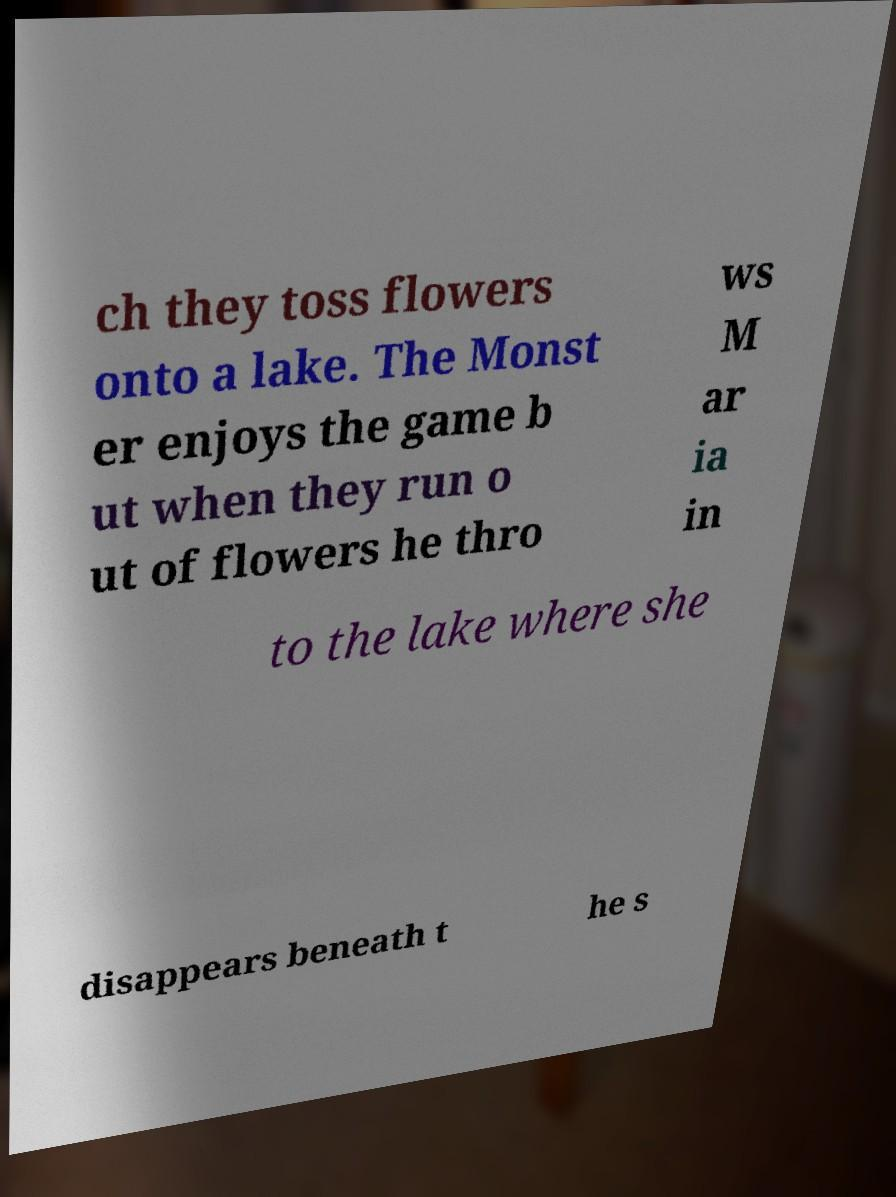What messages or text are displayed in this image? I need them in a readable, typed format. ch they toss flowers onto a lake. The Monst er enjoys the game b ut when they run o ut of flowers he thro ws M ar ia in to the lake where she disappears beneath t he s 